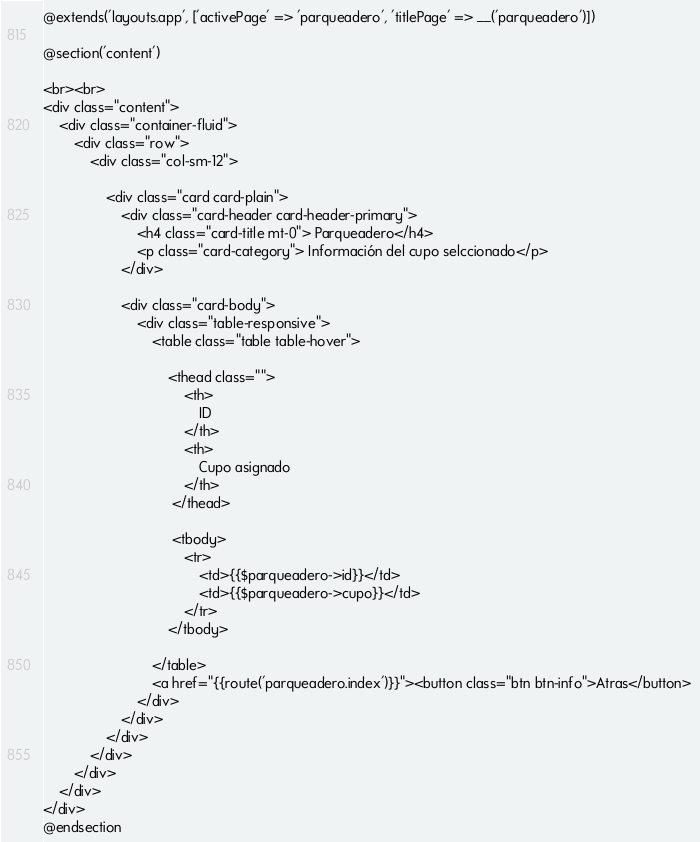<code> <loc_0><loc_0><loc_500><loc_500><_PHP_>@extends('layouts.app', ['activePage' => 'parqueadero', 'titlePage' => __('parqueadero')])

@section('content')

<br><br>
<div class="content">
    <div class="container-fluid">
        <div class="row">
            <div class="col-sm-12">

                <div class="card card-plain">
                    <div class="card-header card-header-primary">
                        <h4 class="card-title mt-0"> Parqueadero</h4>
                        <p class="card-category"> Información del cupo selccionado</p>
                    </div>

                    <div class="card-body">
                        <div class="table-responsive">
                            <table class="table table-hover">

                                <thead class="">
                                    <th>
                                        ID
                                    </th>
                                    <th>
                                        Cupo asignado
                                    </th>                                    
                                 </thead>

                                 <tbody>
                                    <tr>
                                        <td>{{$parqueadero->id}}</td>
                                        <td>{{$parqueadero->cupo}}</td>                                                                      
                                    </tr>
                                </tbody>

                            </table>
                            <a href="{{route('parqueadero.index')}}"><button class="btn btn-info">Atras</button>
                        </div>
                    </div>
                </div>
            </div>    
        </div> 
    </div>
</div>
@endsection</code> 